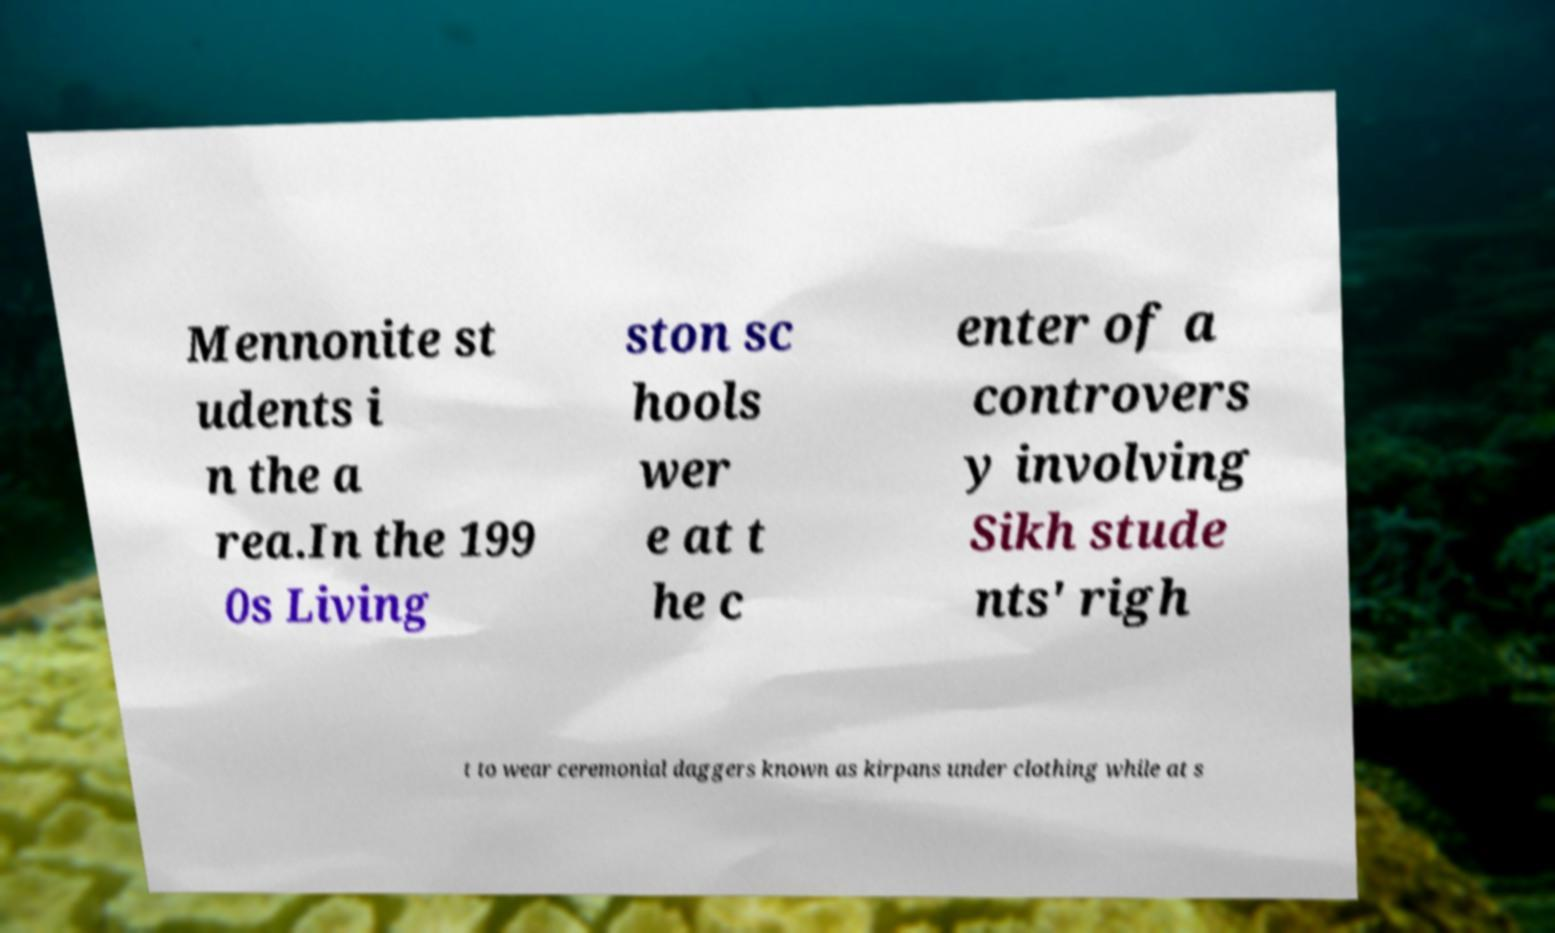Can you read and provide the text displayed in the image?This photo seems to have some interesting text. Can you extract and type it out for me? Mennonite st udents i n the a rea.In the 199 0s Living ston sc hools wer e at t he c enter of a controvers y involving Sikh stude nts' righ t to wear ceremonial daggers known as kirpans under clothing while at s 